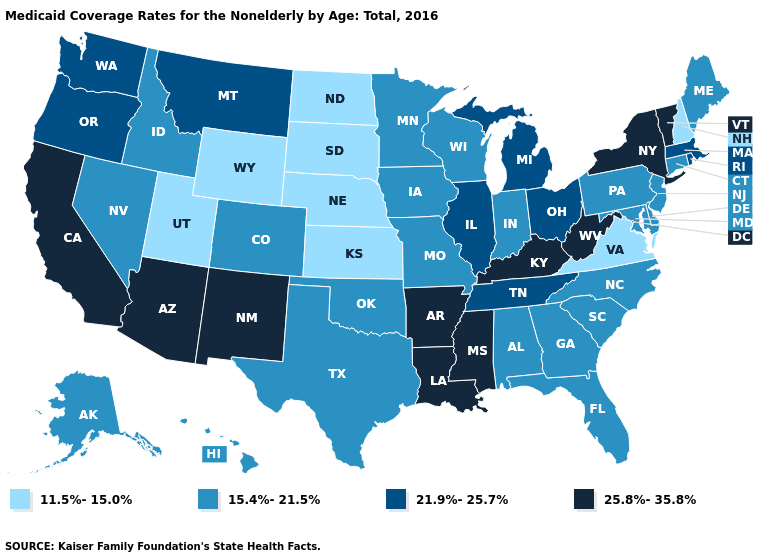Name the states that have a value in the range 21.9%-25.7%?
Keep it brief. Illinois, Massachusetts, Michigan, Montana, Ohio, Oregon, Rhode Island, Tennessee, Washington. What is the value of Wisconsin?
Give a very brief answer. 15.4%-21.5%. What is the value of Massachusetts?
Give a very brief answer. 21.9%-25.7%. Which states have the lowest value in the South?
Concise answer only. Virginia. What is the lowest value in the USA?
Be succinct. 11.5%-15.0%. What is the lowest value in the USA?
Quick response, please. 11.5%-15.0%. Does Ohio have the lowest value in the USA?
Quick response, please. No. How many symbols are there in the legend?
Quick response, please. 4. What is the value of Pennsylvania?
Answer briefly. 15.4%-21.5%. What is the lowest value in states that border Arizona?
Answer briefly. 11.5%-15.0%. Name the states that have a value in the range 15.4%-21.5%?
Answer briefly. Alabama, Alaska, Colorado, Connecticut, Delaware, Florida, Georgia, Hawaii, Idaho, Indiana, Iowa, Maine, Maryland, Minnesota, Missouri, Nevada, New Jersey, North Carolina, Oklahoma, Pennsylvania, South Carolina, Texas, Wisconsin. What is the value of Colorado?
Concise answer only. 15.4%-21.5%. Name the states that have a value in the range 11.5%-15.0%?
Short answer required. Kansas, Nebraska, New Hampshire, North Dakota, South Dakota, Utah, Virginia, Wyoming. What is the value of Kansas?
Keep it brief. 11.5%-15.0%. What is the highest value in states that border Pennsylvania?
Short answer required. 25.8%-35.8%. 